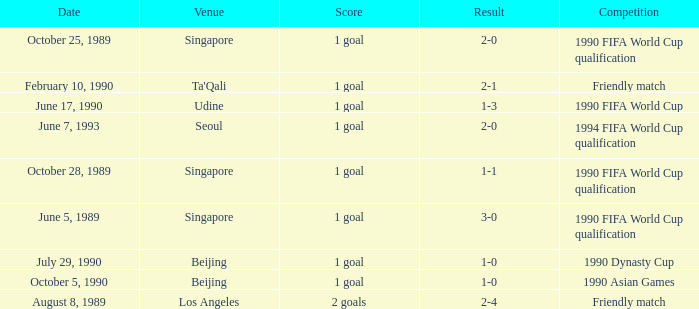What was the venue where the result was 2-1? Ta'Qali. 